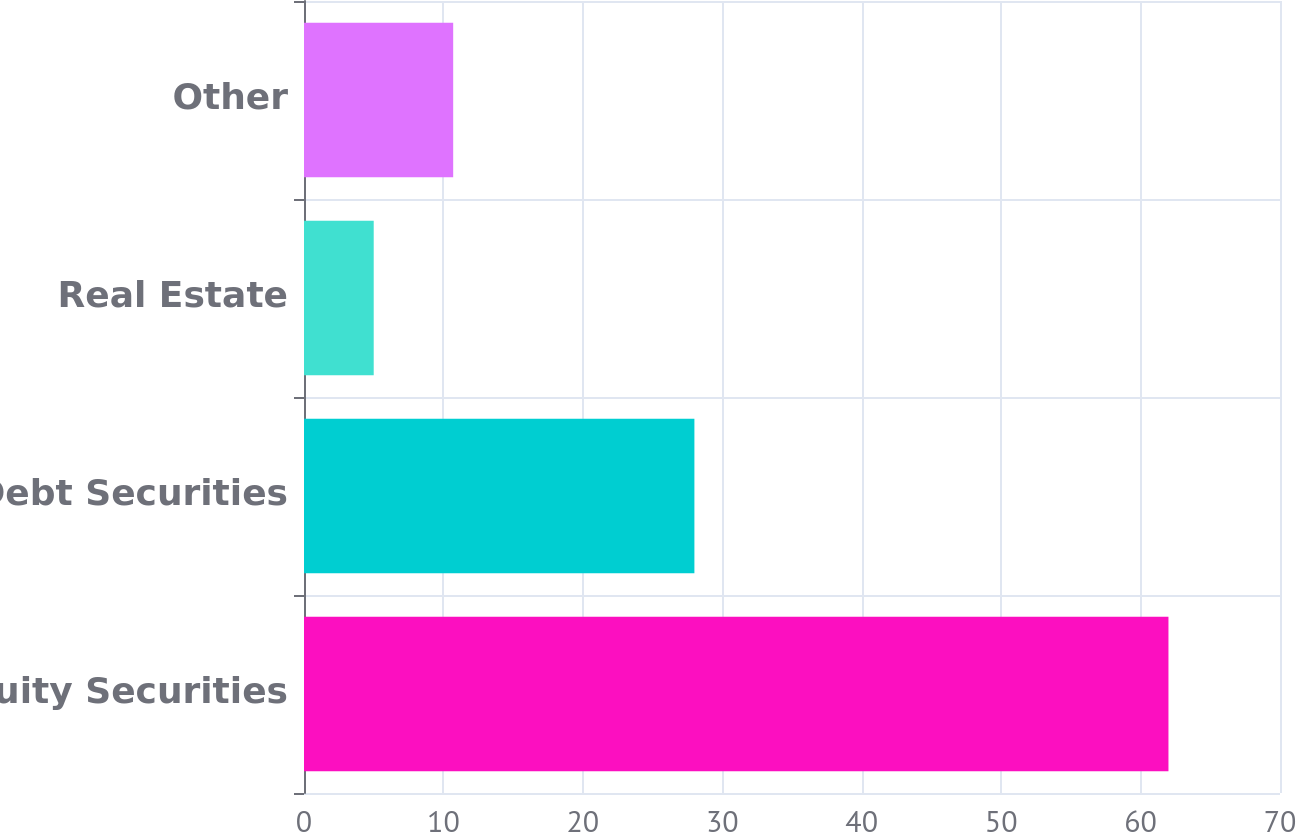Convert chart. <chart><loc_0><loc_0><loc_500><loc_500><bar_chart><fcel>Equity Securities<fcel>Debt Securities<fcel>Real Estate<fcel>Other<nl><fcel>62<fcel>28<fcel>5<fcel>10.7<nl></chart> 